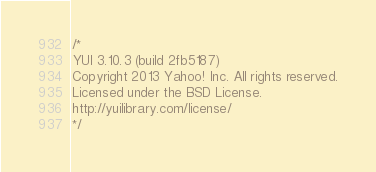<code> <loc_0><loc_0><loc_500><loc_500><_CSS_>/*
YUI 3.10.3 (build 2fb5187)
Copyright 2013 Yahoo! Inc. All rights reserved.
Licensed under the BSD License.
http://yuilibrary.com/license/
*/
</code> 